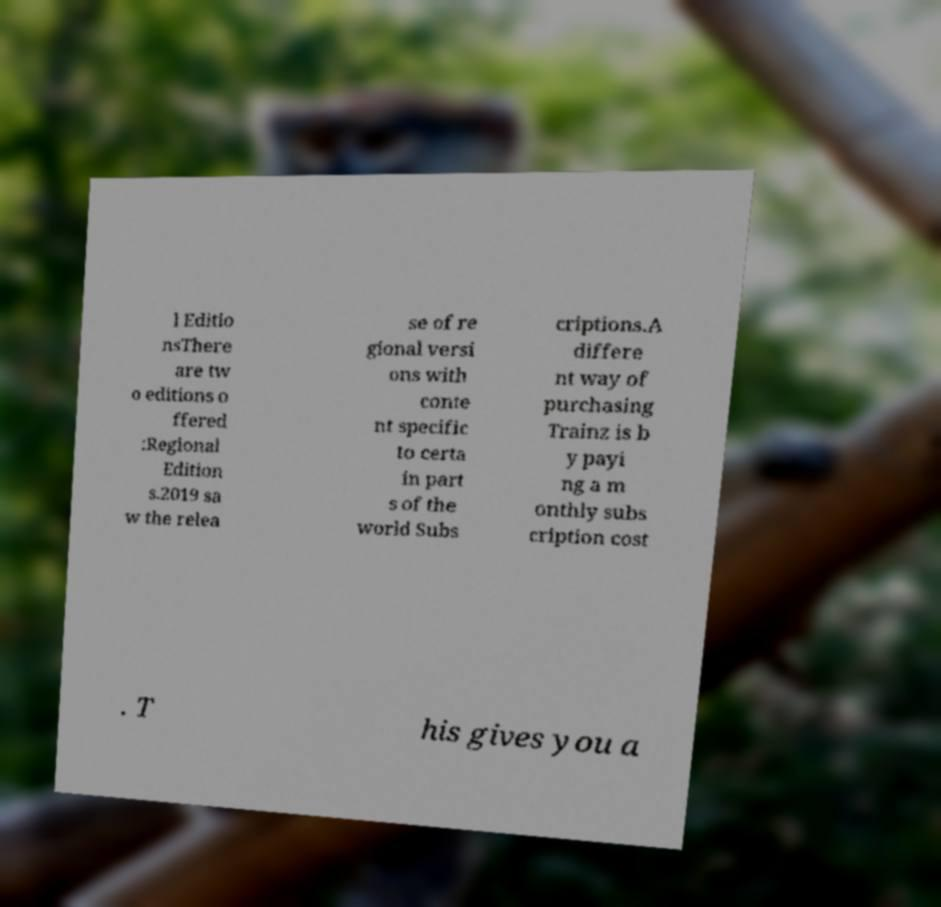Please read and relay the text visible in this image. What does it say? l Editio nsThere are tw o editions o ffered :Regional Edition s.2019 sa w the relea se of re gional versi ons with conte nt specific to certa in part s of the world Subs criptions.A differe nt way of purchasing Trainz is b y payi ng a m onthly subs cription cost . T his gives you a 